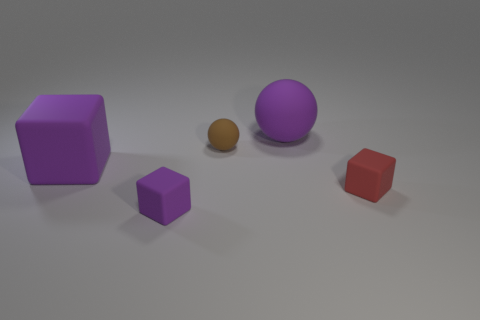Subtract all yellow spheres. Subtract all yellow cylinders. How many spheres are left? 2 Add 2 small green rubber cylinders. How many objects exist? 7 Subtract all blocks. How many objects are left? 2 Subtract 0 gray spheres. How many objects are left? 5 Subtract all large purple blocks. Subtract all small rubber cubes. How many objects are left? 2 Add 4 rubber balls. How many rubber balls are left? 6 Add 3 small yellow metal spheres. How many small yellow metal spheres exist? 3 